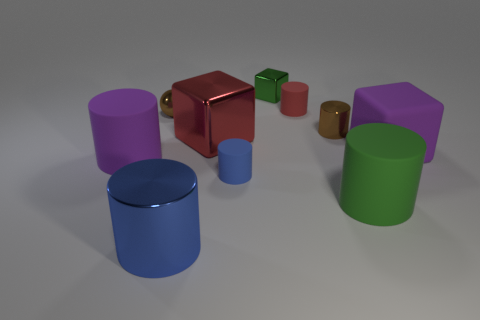There is a thing that is the same color as the big matte block; what is its shape?
Provide a succinct answer. Cylinder. How many blue metallic things have the same shape as the green matte object?
Your answer should be compact. 1. What is the size of the object that is the same color as the metal sphere?
Ensure brevity in your answer.  Small. What color is the cylinder that is in front of the small blue matte cylinder and on the left side of the blue rubber thing?
Ensure brevity in your answer.  Blue. Is the brown cylinder the same size as the green block?
Provide a succinct answer. Yes. There is a metallic block that is to the right of the red cube; what color is it?
Keep it short and to the point. Green. Are there any blocks of the same color as the small shiny cylinder?
Offer a terse response. No. What color is the metal cylinder that is the same size as the purple matte cube?
Offer a very short reply. Blue. Is the shape of the large red thing the same as the tiny green metallic object?
Offer a terse response. Yes. What is the thing that is in front of the large green matte thing made of?
Offer a terse response. Metal. 